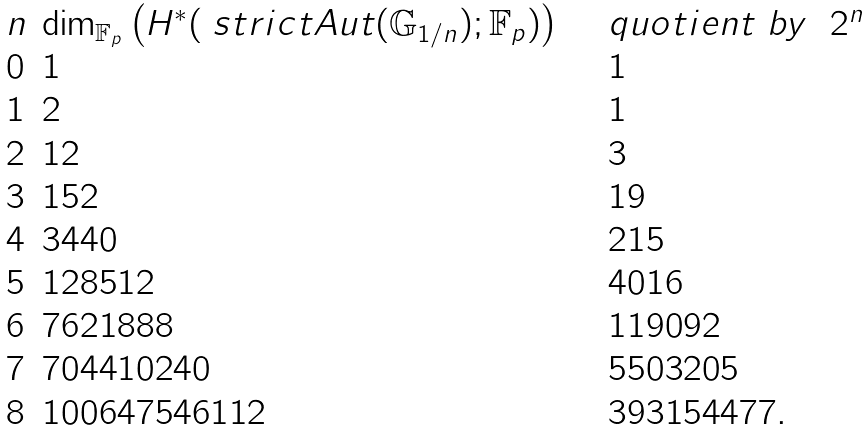Convert formula to latex. <formula><loc_0><loc_0><loc_500><loc_500>\begin{array} { l l l } n & \dim _ { \mathbb { F } _ { p } } \left ( H ^ { * } ( \ s t r i c t A u t ( \mathbb { G } _ { 1 / n } ) ; \mathbb { F } _ { p } ) \right ) \quad & q u o t i e n t \ b y \ \ 2 ^ { n } \\ 0 & 1 & 1 \\ 1 & 2 & 1 \\ 2 & 1 2 & 3 \\ 3 & 1 5 2 & 1 9 \\ 4 & 3 4 4 0 & 2 1 5 \\ 5 & 1 2 8 5 1 2 & 4 0 1 6 \\ 6 & 7 6 2 1 8 8 8 & 1 1 9 0 9 2 \\ 7 & 7 0 4 4 1 0 2 4 0 & 5 5 0 3 2 0 5 \\ 8 & 1 0 0 6 4 7 5 4 6 1 1 2 & 3 9 3 1 5 4 4 7 7 . \end{array}</formula> 